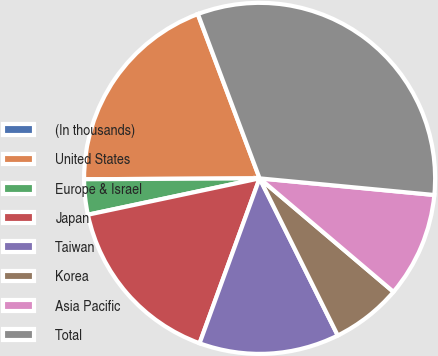Convert chart to OTSL. <chart><loc_0><loc_0><loc_500><loc_500><pie_chart><fcel>(In thousands)<fcel>United States<fcel>Europe & Israel<fcel>Japan<fcel>Taiwan<fcel>Korea<fcel>Asia Pacific<fcel>Total<nl><fcel>0.02%<fcel>19.34%<fcel>3.24%<fcel>16.12%<fcel>12.9%<fcel>6.46%<fcel>9.68%<fcel>32.22%<nl></chart> 